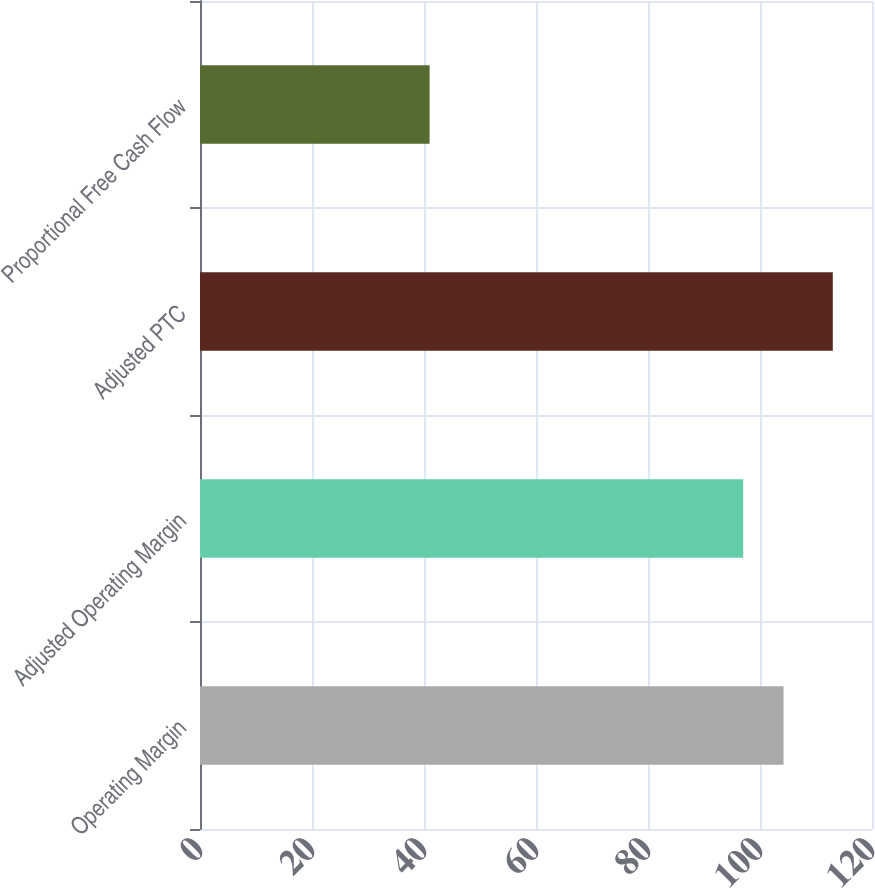Convert chart. <chart><loc_0><loc_0><loc_500><loc_500><bar_chart><fcel>Operating Margin<fcel>Adjusted Operating Margin<fcel>Adjusted PTC<fcel>Proportional Free Cash Flow<nl><fcel>104.2<fcel>97<fcel>113<fcel>41<nl></chart> 